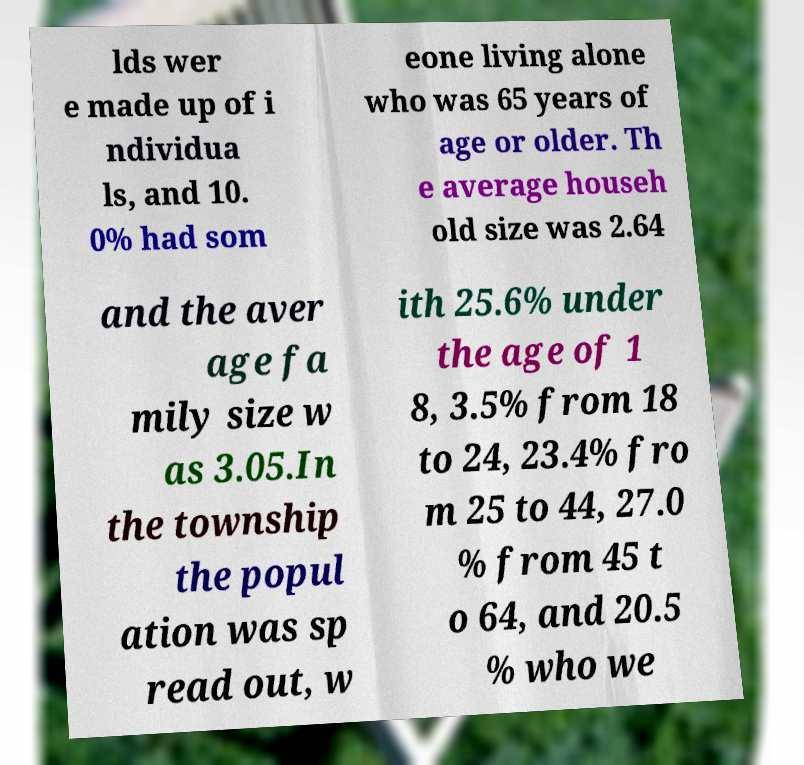Could you assist in decoding the text presented in this image and type it out clearly? lds wer e made up of i ndividua ls, and 10. 0% had som eone living alone who was 65 years of age or older. Th e average househ old size was 2.64 and the aver age fa mily size w as 3.05.In the township the popul ation was sp read out, w ith 25.6% under the age of 1 8, 3.5% from 18 to 24, 23.4% fro m 25 to 44, 27.0 % from 45 t o 64, and 20.5 % who we 